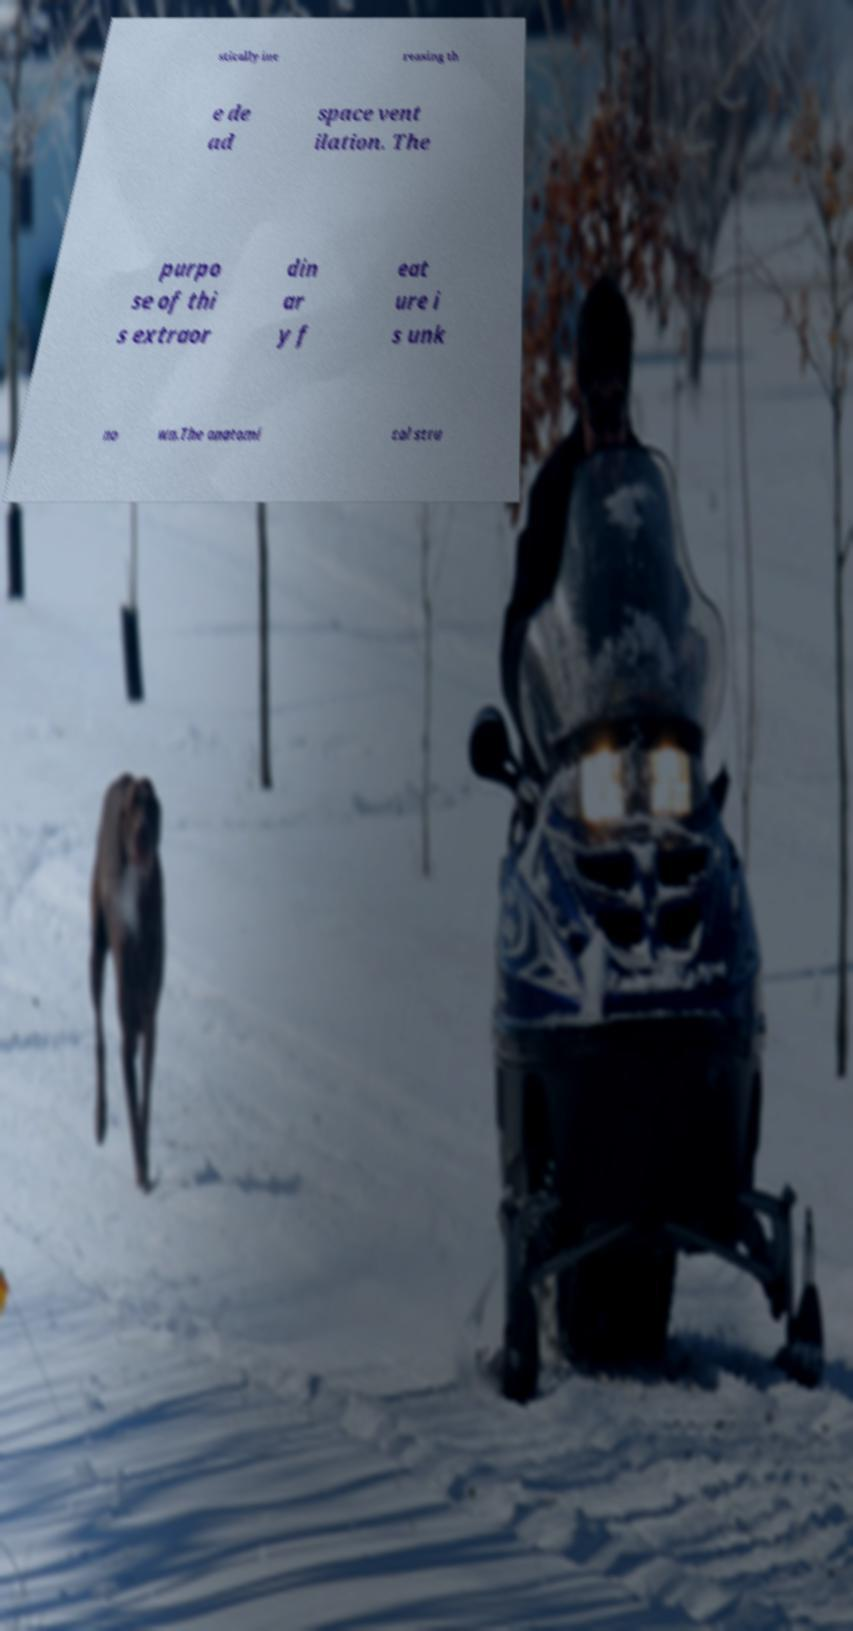Could you assist in decoding the text presented in this image and type it out clearly? stically inc reasing th e de ad space vent ilation. The purpo se of thi s extraor din ar y f eat ure i s unk no wn.The anatomi cal stru 